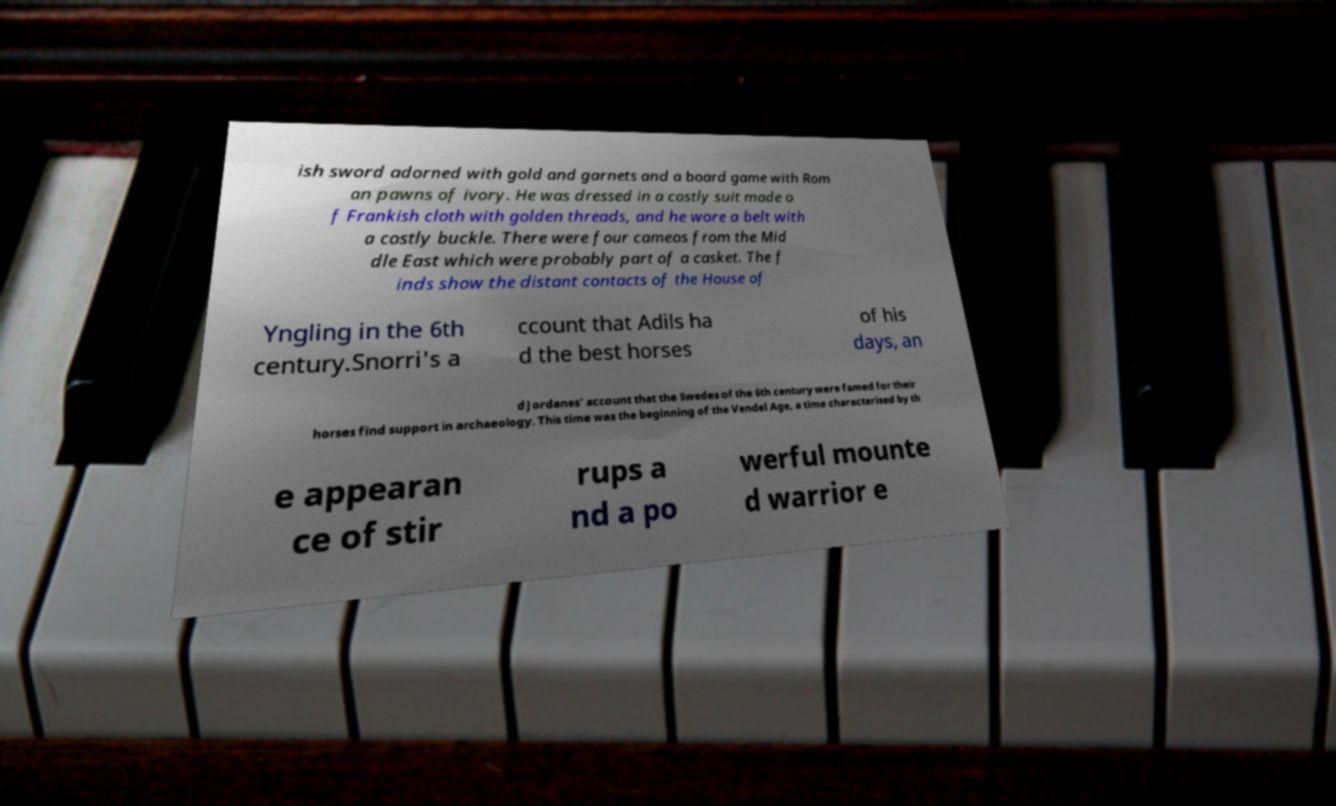Please identify and transcribe the text found in this image. ish sword adorned with gold and garnets and a board game with Rom an pawns of ivory. He was dressed in a costly suit made o f Frankish cloth with golden threads, and he wore a belt with a costly buckle. There were four cameos from the Mid dle East which were probably part of a casket. The f inds show the distant contacts of the House of Yngling in the 6th century.Snorri's a ccount that Adils ha d the best horses of his days, an d Jordanes' account that the Swedes of the 6th century were famed for their horses find support in archaeology. This time was the beginning of the Vendel Age, a time characterised by th e appearan ce of stir rups a nd a po werful mounte d warrior e 